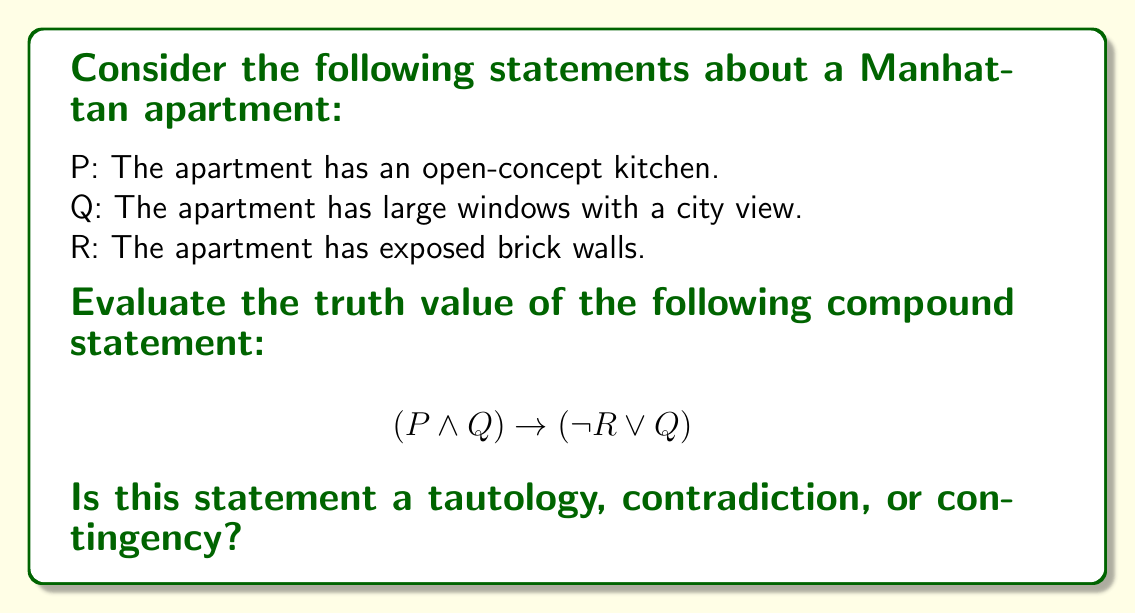Give your solution to this math problem. To determine whether the given compound statement is a tautology, contradiction, or contingency, we need to evaluate its truth value for all possible combinations of P, Q, and R.

Let's create a truth table:

$$\begin{array}{|c|c|c|c|c|c|c|}
\hline
P & Q & R & P \wedge Q & \neg R & \neg R \vee Q & (P \wedge Q) \rightarrow (\neg R \vee Q) \\
\hline
T & T & T & T & F & T & T \\
T & T & F & T & T & T & T \\
T & F & T & F & F & F & T \\
T & F & F & F & T & T & T \\
F & T & T & F & F & T & T \\
F & T & F & F & T & T & T \\
F & F & T & F & F & F & T \\
F & F & F & F & T & T & T \\
\hline
\end{array}$$

We evaluate the compound statement column by column:

1. $P \wedge Q$: True only when both P and Q are true.
2. $\neg R$: True when R is false.
3. $\neg R \vee Q$: True when either $\neg R$ is true or Q is true (or both).
4. $(P \wedge Q) \rightarrow (\neg R \vee Q)$: This is the main statement we're evaluating. It's true when either $(P \wedge Q)$ is false or $(\neg R \vee Q)$ is true (or both).

Looking at the final column, we see that the compound statement is true for all possible combinations of P, Q, and R.

When a compound statement is true for all possible truth values of its component statements, it is called a tautology.
Answer: The compound statement $(P \wedge Q) \rightarrow (\neg R \vee Q)$ is a tautology. 